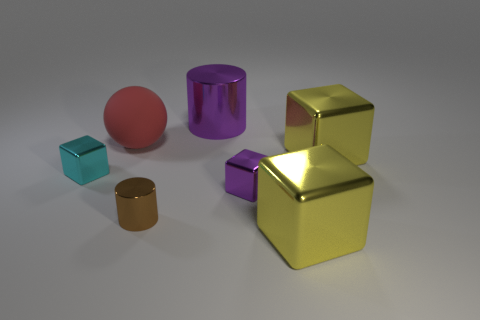Subtract all gray blocks. Subtract all green cylinders. How many blocks are left? 4 Add 1 big purple rubber cubes. How many objects exist? 8 Subtract all blocks. How many objects are left? 3 Subtract 1 purple cylinders. How many objects are left? 6 Subtract all large purple things. Subtract all large yellow blocks. How many objects are left? 4 Add 1 tiny cyan metal blocks. How many tiny cyan metal blocks are left? 2 Add 6 yellow rubber balls. How many yellow rubber balls exist? 6 